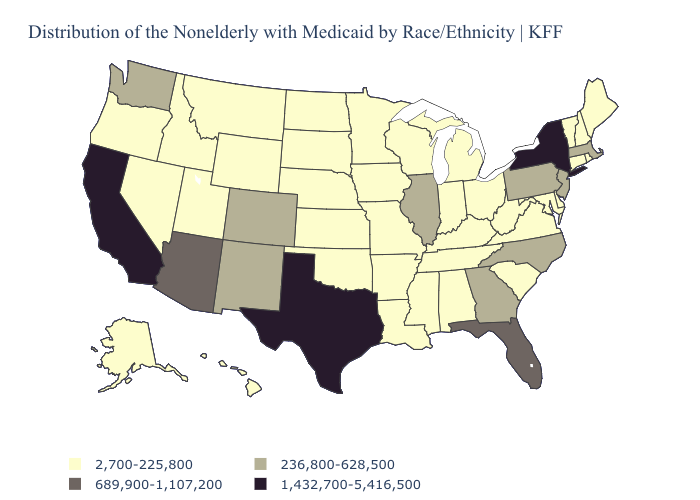Does New York have the lowest value in the Northeast?
Answer briefly. No. Name the states that have a value in the range 2,700-225,800?
Short answer required. Alabama, Alaska, Arkansas, Connecticut, Delaware, Hawaii, Idaho, Indiana, Iowa, Kansas, Kentucky, Louisiana, Maine, Maryland, Michigan, Minnesota, Mississippi, Missouri, Montana, Nebraska, Nevada, New Hampshire, North Dakota, Ohio, Oklahoma, Oregon, Rhode Island, South Carolina, South Dakota, Tennessee, Utah, Vermont, Virginia, West Virginia, Wisconsin, Wyoming. Which states have the lowest value in the USA?
Quick response, please. Alabama, Alaska, Arkansas, Connecticut, Delaware, Hawaii, Idaho, Indiana, Iowa, Kansas, Kentucky, Louisiana, Maine, Maryland, Michigan, Minnesota, Mississippi, Missouri, Montana, Nebraska, Nevada, New Hampshire, North Dakota, Ohio, Oklahoma, Oregon, Rhode Island, South Carolina, South Dakota, Tennessee, Utah, Vermont, Virginia, West Virginia, Wisconsin, Wyoming. What is the lowest value in the USA?
Write a very short answer. 2,700-225,800. What is the lowest value in states that border Nebraska?
Short answer required. 2,700-225,800. Name the states that have a value in the range 1,432,700-5,416,500?
Write a very short answer. California, New York, Texas. Among the states that border New York , which have the lowest value?
Quick response, please. Connecticut, Vermont. How many symbols are there in the legend?
Concise answer only. 4. Name the states that have a value in the range 236,800-628,500?
Short answer required. Colorado, Georgia, Illinois, Massachusetts, New Jersey, New Mexico, North Carolina, Pennsylvania, Washington. Does the first symbol in the legend represent the smallest category?
Write a very short answer. Yes. Name the states that have a value in the range 689,900-1,107,200?
Give a very brief answer. Arizona, Florida. Name the states that have a value in the range 2,700-225,800?
Write a very short answer. Alabama, Alaska, Arkansas, Connecticut, Delaware, Hawaii, Idaho, Indiana, Iowa, Kansas, Kentucky, Louisiana, Maine, Maryland, Michigan, Minnesota, Mississippi, Missouri, Montana, Nebraska, Nevada, New Hampshire, North Dakota, Ohio, Oklahoma, Oregon, Rhode Island, South Carolina, South Dakota, Tennessee, Utah, Vermont, Virginia, West Virginia, Wisconsin, Wyoming. Name the states that have a value in the range 236,800-628,500?
Concise answer only. Colorado, Georgia, Illinois, Massachusetts, New Jersey, New Mexico, North Carolina, Pennsylvania, Washington. Name the states that have a value in the range 1,432,700-5,416,500?
Write a very short answer. California, New York, Texas. Which states have the lowest value in the USA?
Give a very brief answer. Alabama, Alaska, Arkansas, Connecticut, Delaware, Hawaii, Idaho, Indiana, Iowa, Kansas, Kentucky, Louisiana, Maine, Maryland, Michigan, Minnesota, Mississippi, Missouri, Montana, Nebraska, Nevada, New Hampshire, North Dakota, Ohio, Oklahoma, Oregon, Rhode Island, South Carolina, South Dakota, Tennessee, Utah, Vermont, Virginia, West Virginia, Wisconsin, Wyoming. 